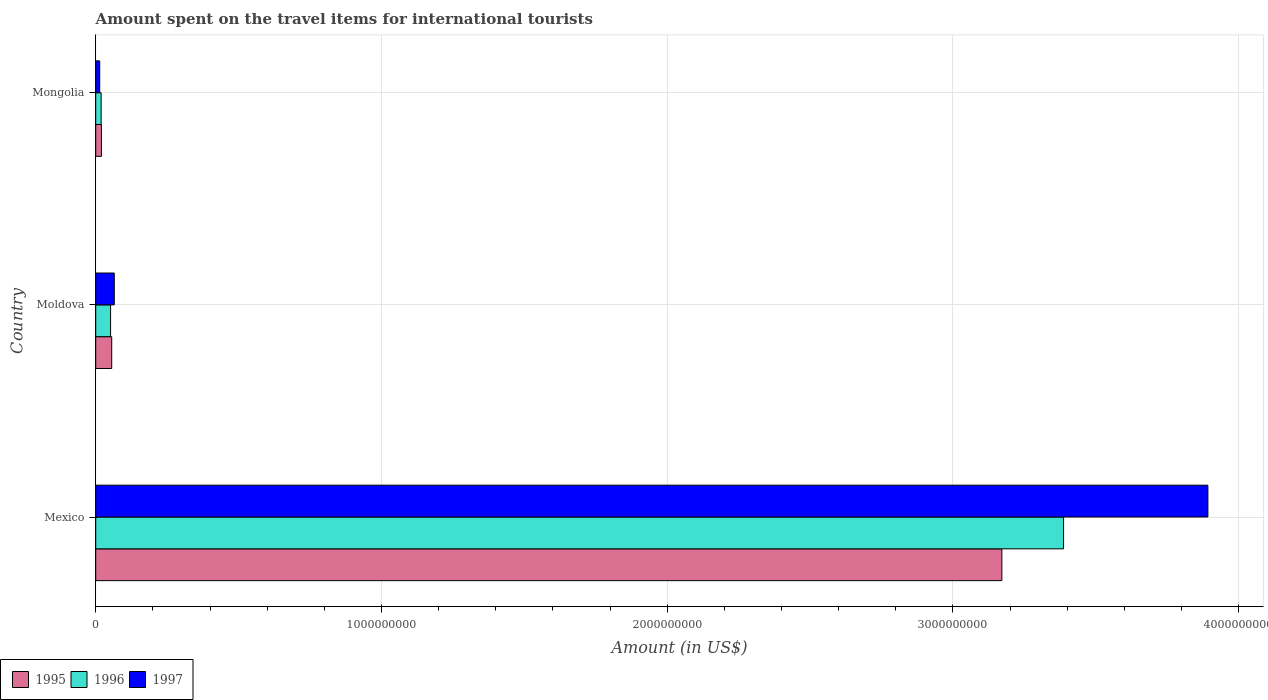Are the number of bars per tick equal to the number of legend labels?
Your response must be concise. Yes. Are the number of bars on each tick of the Y-axis equal?
Your response must be concise. Yes. How many bars are there on the 2nd tick from the bottom?
Offer a very short reply. 3. What is the label of the 2nd group of bars from the top?
Keep it short and to the point. Moldova. In how many cases, is the number of bars for a given country not equal to the number of legend labels?
Offer a terse response. 0. Across all countries, what is the maximum amount spent on the travel items for international tourists in 1996?
Provide a succinct answer. 3.39e+09. Across all countries, what is the minimum amount spent on the travel items for international tourists in 1995?
Offer a terse response. 2.00e+07. In which country was the amount spent on the travel items for international tourists in 1995 minimum?
Keep it short and to the point. Mongolia. What is the total amount spent on the travel items for international tourists in 1997 in the graph?
Your answer should be compact. 3.97e+09. What is the difference between the amount spent on the travel items for international tourists in 1996 in Moldova and that in Mongolia?
Provide a short and direct response. 3.30e+07. What is the difference between the amount spent on the travel items for international tourists in 1995 in Mongolia and the amount spent on the travel items for international tourists in 1997 in Mexico?
Make the answer very short. -3.87e+09. What is the average amount spent on the travel items for international tourists in 1995 per country?
Provide a short and direct response. 1.08e+09. What is the difference between the amount spent on the travel items for international tourists in 1996 and amount spent on the travel items for international tourists in 1997 in Mongolia?
Keep it short and to the point. 5.00e+06. In how many countries, is the amount spent on the travel items for international tourists in 1996 greater than 2600000000 US$?
Your response must be concise. 1. Is the difference between the amount spent on the travel items for international tourists in 1996 in Mexico and Moldova greater than the difference between the amount spent on the travel items for international tourists in 1997 in Mexico and Moldova?
Offer a terse response. No. What is the difference between the highest and the second highest amount spent on the travel items for international tourists in 1995?
Offer a very short reply. 3.12e+09. What is the difference between the highest and the lowest amount spent on the travel items for international tourists in 1995?
Make the answer very short. 3.15e+09. What does the 1st bar from the top in Mexico represents?
Make the answer very short. 1997. What does the 1st bar from the bottom in Moldova represents?
Your answer should be compact. 1995. How many bars are there?
Your response must be concise. 9. Are all the bars in the graph horizontal?
Provide a short and direct response. Yes. What is the difference between two consecutive major ticks on the X-axis?
Keep it short and to the point. 1.00e+09. Are the values on the major ticks of X-axis written in scientific E-notation?
Offer a terse response. No. Does the graph contain any zero values?
Provide a short and direct response. No. Does the graph contain grids?
Make the answer very short. Yes. Where does the legend appear in the graph?
Offer a very short reply. Bottom left. What is the title of the graph?
Give a very brief answer. Amount spent on the travel items for international tourists. Does "1983" appear as one of the legend labels in the graph?
Provide a succinct answer. No. What is the label or title of the X-axis?
Ensure brevity in your answer.  Amount (in US$). What is the Amount (in US$) in 1995 in Mexico?
Make the answer very short. 3.17e+09. What is the Amount (in US$) in 1996 in Mexico?
Give a very brief answer. 3.39e+09. What is the Amount (in US$) of 1997 in Mexico?
Provide a short and direct response. 3.89e+09. What is the Amount (in US$) in 1995 in Moldova?
Your answer should be very brief. 5.60e+07. What is the Amount (in US$) of 1996 in Moldova?
Your answer should be compact. 5.20e+07. What is the Amount (in US$) in 1997 in Moldova?
Your answer should be compact. 6.50e+07. What is the Amount (in US$) of 1995 in Mongolia?
Ensure brevity in your answer.  2.00e+07. What is the Amount (in US$) in 1996 in Mongolia?
Offer a terse response. 1.90e+07. What is the Amount (in US$) of 1997 in Mongolia?
Keep it short and to the point. 1.40e+07. Across all countries, what is the maximum Amount (in US$) in 1995?
Your answer should be compact. 3.17e+09. Across all countries, what is the maximum Amount (in US$) in 1996?
Give a very brief answer. 3.39e+09. Across all countries, what is the maximum Amount (in US$) in 1997?
Ensure brevity in your answer.  3.89e+09. Across all countries, what is the minimum Amount (in US$) of 1996?
Ensure brevity in your answer.  1.90e+07. Across all countries, what is the minimum Amount (in US$) of 1997?
Keep it short and to the point. 1.40e+07. What is the total Amount (in US$) in 1995 in the graph?
Give a very brief answer. 3.25e+09. What is the total Amount (in US$) in 1996 in the graph?
Keep it short and to the point. 3.46e+09. What is the total Amount (in US$) in 1997 in the graph?
Your response must be concise. 3.97e+09. What is the difference between the Amount (in US$) of 1995 in Mexico and that in Moldova?
Keep it short and to the point. 3.12e+09. What is the difference between the Amount (in US$) of 1996 in Mexico and that in Moldova?
Make the answer very short. 3.34e+09. What is the difference between the Amount (in US$) in 1997 in Mexico and that in Moldova?
Provide a short and direct response. 3.83e+09. What is the difference between the Amount (in US$) in 1995 in Mexico and that in Mongolia?
Provide a short and direct response. 3.15e+09. What is the difference between the Amount (in US$) in 1996 in Mexico and that in Mongolia?
Keep it short and to the point. 3.37e+09. What is the difference between the Amount (in US$) in 1997 in Mexico and that in Mongolia?
Your answer should be very brief. 3.88e+09. What is the difference between the Amount (in US$) of 1995 in Moldova and that in Mongolia?
Provide a succinct answer. 3.60e+07. What is the difference between the Amount (in US$) of 1996 in Moldova and that in Mongolia?
Your response must be concise. 3.30e+07. What is the difference between the Amount (in US$) of 1997 in Moldova and that in Mongolia?
Make the answer very short. 5.10e+07. What is the difference between the Amount (in US$) of 1995 in Mexico and the Amount (in US$) of 1996 in Moldova?
Give a very brief answer. 3.12e+09. What is the difference between the Amount (in US$) of 1995 in Mexico and the Amount (in US$) of 1997 in Moldova?
Make the answer very short. 3.11e+09. What is the difference between the Amount (in US$) of 1996 in Mexico and the Amount (in US$) of 1997 in Moldova?
Offer a very short reply. 3.32e+09. What is the difference between the Amount (in US$) of 1995 in Mexico and the Amount (in US$) of 1996 in Mongolia?
Offer a very short reply. 3.15e+09. What is the difference between the Amount (in US$) in 1995 in Mexico and the Amount (in US$) in 1997 in Mongolia?
Your response must be concise. 3.16e+09. What is the difference between the Amount (in US$) of 1996 in Mexico and the Amount (in US$) of 1997 in Mongolia?
Provide a short and direct response. 3.37e+09. What is the difference between the Amount (in US$) of 1995 in Moldova and the Amount (in US$) of 1996 in Mongolia?
Offer a very short reply. 3.70e+07. What is the difference between the Amount (in US$) in 1995 in Moldova and the Amount (in US$) in 1997 in Mongolia?
Your answer should be very brief. 4.20e+07. What is the difference between the Amount (in US$) in 1996 in Moldova and the Amount (in US$) in 1997 in Mongolia?
Keep it short and to the point. 3.80e+07. What is the average Amount (in US$) of 1995 per country?
Your response must be concise. 1.08e+09. What is the average Amount (in US$) in 1996 per country?
Provide a succinct answer. 1.15e+09. What is the average Amount (in US$) of 1997 per country?
Keep it short and to the point. 1.32e+09. What is the difference between the Amount (in US$) of 1995 and Amount (in US$) of 1996 in Mexico?
Your answer should be compact. -2.16e+08. What is the difference between the Amount (in US$) of 1995 and Amount (in US$) of 1997 in Mexico?
Your response must be concise. -7.21e+08. What is the difference between the Amount (in US$) of 1996 and Amount (in US$) of 1997 in Mexico?
Give a very brief answer. -5.05e+08. What is the difference between the Amount (in US$) of 1995 and Amount (in US$) of 1997 in Moldova?
Ensure brevity in your answer.  -9.00e+06. What is the difference between the Amount (in US$) in 1996 and Amount (in US$) in 1997 in Moldova?
Give a very brief answer. -1.30e+07. What is the difference between the Amount (in US$) in 1995 and Amount (in US$) in 1996 in Mongolia?
Your answer should be very brief. 1.00e+06. What is the ratio of the Amount (in US$) in 1995 in Mexico to that in Moldova?
Provide a short and direct response. 56.62. What is the ratio of the Amount (in US$) in 1996 in Mexico to that in Moldova?
Give a very brief answer. 65.13. What is the ratio of the Amount (in US$) in 1997 in Mexico to that in Moldova?
Offer a very short reply. 59.88. What is the ratio of the Amount (in US$) of 1995 in Mexico to that in Mongolia?
Offer a very short reply. 158.55. What is the ratio of the Amount (in US$) of 1996 in Mexico to that in Mongolia?
Make the answer very short. 178.26. What is the ratio of the Amount (in US$) of 1997 in Mexico to that in Mongolia?
Provide a short and direct response. 278. What is the ratio of the Amount (in US$) in 1996 in Moldova to that in Mongolia?
Offer a very short reply. 2.74. What is the ratio of the Amount (in US$) in 1997 in Moldova to that in Mongolia?
Keep it short and to the point. 4.64. What is the difference between the highest and the second highest Amount (in US$) of 1995?
Provide a succinct answer. 3.12e+09. What is the difference between the highest and the second highest Amount (in US$) in 1996?
Keep it short and to the point. 3.34e+09. What is the difference between the highest and the second highest Amount (in US$) of 1997?
Your answer should be compact. 3.83e+09. What is the difference between the highest and the lowest Amount (in US$) in 1995?
Offer a very short reply. 3.15e+09. What is the difference between the highest and the lowest Amount (in US$) in 1996?
Offer a very short reply. 3.37e+09. What is the difference between the highest and the lowest Amount (in US$) of 1997?
Ensure brevity in your answer.  3.88e+09. 